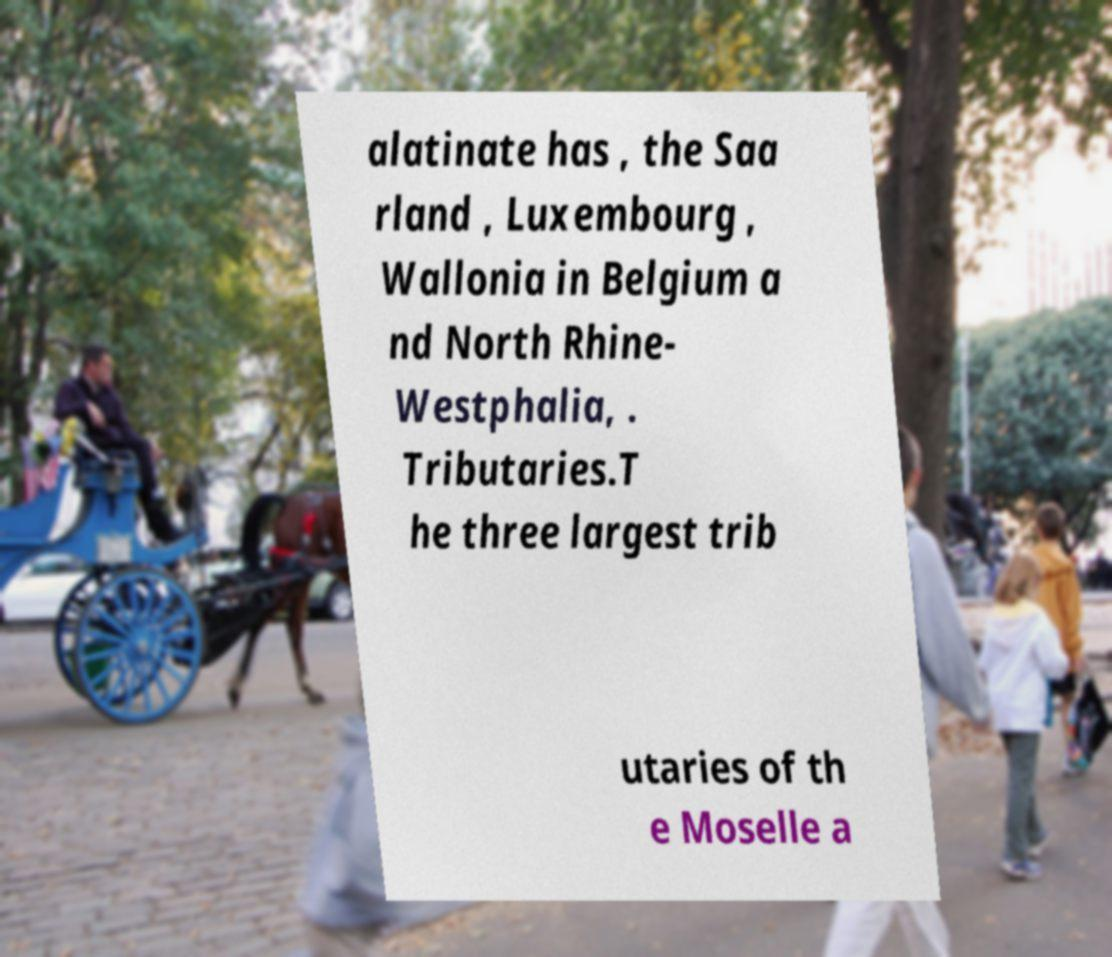Can you accurately transcribe the text from the provided image for me? alatinate has , the Saa rland , Luxembourg , Wallonia in Belgium a nd North Rhine- Westphalia, . Tributaries.T he three largest trib utaries of th e Moselle a 